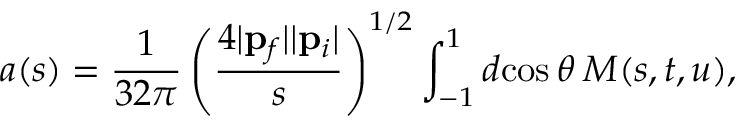Convert formula to latex. <formula><loc_0><loc_0><loc_500><loc_500>a ( s ) = \frac { 1 } { 3 2 \pi } \left ( \frac { 4 | { p } _ { f } | | { p } _ { i } | } { s } \right ) ^ { 1 / 2 } \int _ { - 1 } ^ { 1 } d \, \cos \theta \, M ( s , t , u ) ,</formula> 